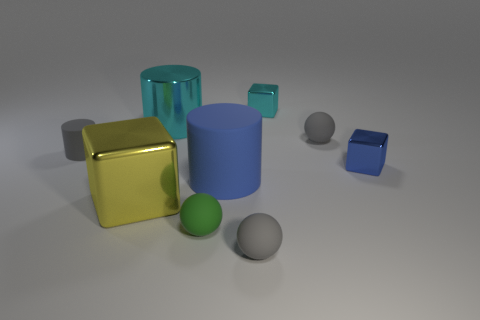Subtract all small cylinders. How many cylinders are left? 2 Add 1 small blue shiny things. How many objects exist? 10 Subtract 1 blocks. How many blocks are left? 2 Subtract all purple cylinders. How many gray spheres are left? 2 Subtract all green cylinders. Subtract all yellow spheres. How many cylinders are left? 3 Subtract all small gray matte cylinders. Subtract all tiny cyan metallic things. How many objects are left? 7 Add 9 large matte cylinders. How many large matte cylinders are left? 10 Add 8 cyan metallic things. How many cyan metallic things exist? 10 Subtract 1 gray cylinders. How many objects are left? 8 